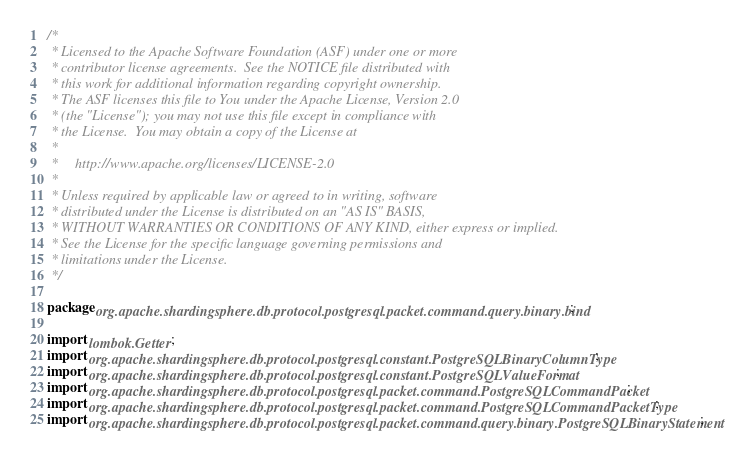<code> <loc_0><loc_0><loc_500><loc_500><_Java_>/*
 * Licensed to the Apache Software Foundation (ASF) under one or more
 * contributor license agreements.  See the NOTICE file distributed with
 * this work for additional information regarding copyright ownership.
 * The ASF licenses this file to You under the Apache License, Version 2.0
 * (the "License"); you may not use this file except in compliance with
 * the License.  You may obtain a copy of the License at
 *
 *     http://www.apache.org/licenses/LICENSE-2.0
 *
 * Unless required by applicable law or agreed to in writing, software
 * distributed under the License is distributed on an "AS IS" BASIS,
 * WITHOUT WARRANTIES OR CONDITIONS OF ANY KIND, either express or implied.
 * See the License for the specific language governing permissions and
 * limitations under the License.
 */

package org.apache.shardingsphere.db.protocol.postgresql.packet.command.query.binary.bind;

import lombok.Getter;
import org.apache.shardingsphere.db.protocol.postgresql.constant.PostgreSQLBinaryColumnType;
import org.apache.shardingsphere.db.protocol.postgresql.constant.PostgreSQLValueFormat;
import org.apache.shardingsphere.db.protocol.postgresql.packet.command.PostgreSQLCommandPacket;
import org.apache.shardingsphere.db.protocol.postgresql.packet.command.PostgreSQLCommandPacketType;
import org.apache.shardingsphere.db.protocol.postgresql.packet.command.query.binary.PostgreSQLBinaryStatement;</code> 